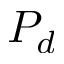Convert formula to latex. <formula><loc_0><loc_0><loc_500><loc_500>P _ { d }</formula> 